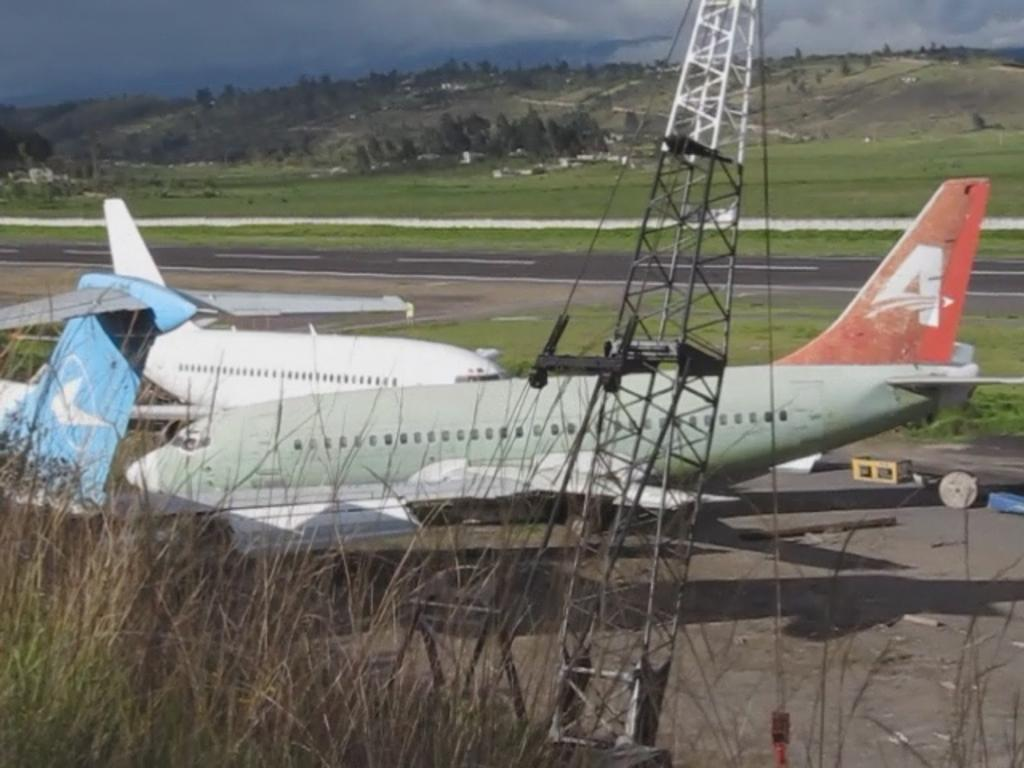<image>
Write a terse but informative summary of the picture. many planes are sitting at the airport, one with an A on its tail 